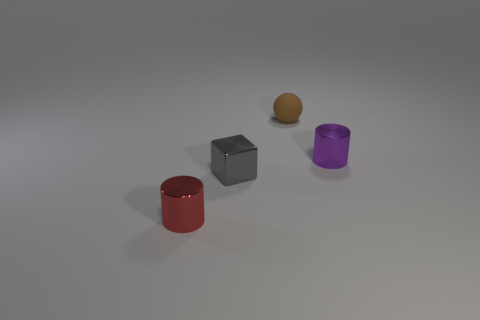Can you describe the texture or material of the objects? Certainly! The red and purple objects appear to have a matte finish and are likely made of plastic. The metal cube, as the name suggests, has a metallic sheen, indicating it is made of metal. The golden sphere has a slightly reflective surface and could be made of polished metal or plastic. 